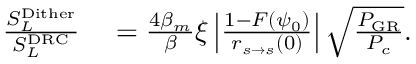<formula> <loc_0><loc_0><loc_500><loc_500>\begin{array} { r l } { \frac { S _ { L } ^ { D i t h e r } } { S _ { L } ^ { D R C } } } & = \frac { 4 \beta _ { m } } { \beta } \xi \left | \frac { 1 - F ( \psi _ { 0 } ) } { r _ { s \rightarrow s } ( 0 ) } \right | \sqrt { \frac { P _ { G R } } { P _ { c } } } . } \end{array}</formula> 